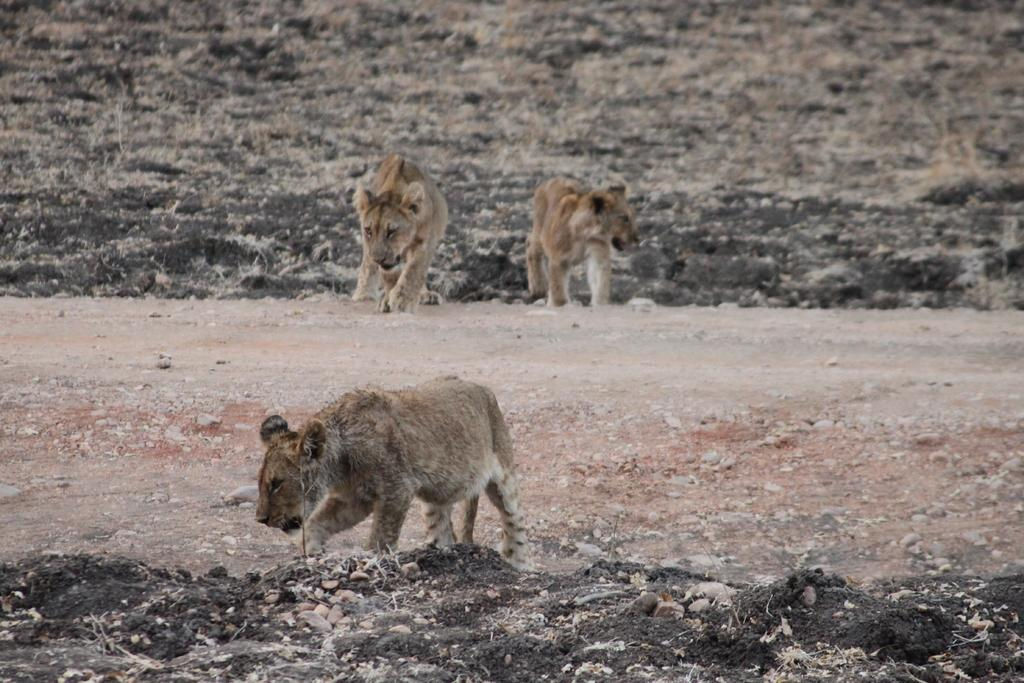How many lions are present in the image? There are three lions in the image. What is the position of the lions in the image? The lions are on the ground. What time of day is it in the image, according to the hour? The provided facts do not mention the time of day or any hour, so it cannot be determined from the image. 